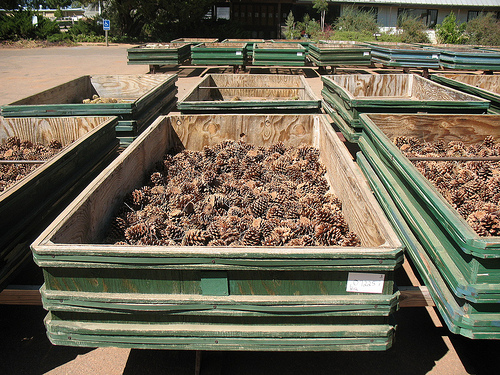<image>
Is there a cones in the basket? Yes. The cones is contained within or inside the basket, showing a containment relationship. 